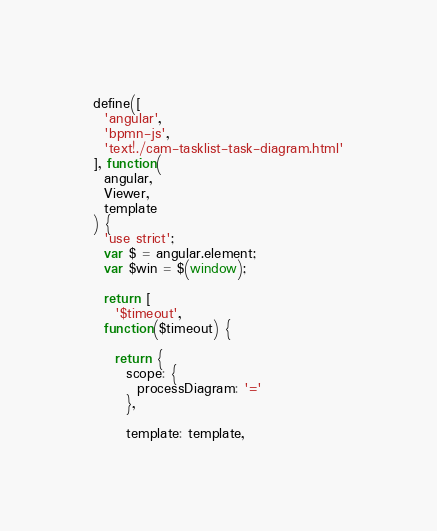Convert code to text. <code><loc_0><loc_0><loc_500><loc_500><_JavaScript_>define([
  'angular',
  'bpmn-js',
  'text!./cam-tasklist-task-diagram.html'
], function(
  angular,
  Viewer,
  template
) {
  'use strict';
  var $ = angular.element;
  var $win = $(window);

  return [
    '$timeout',
  function($timeout) {

    return {
      scope: {
        processDiagram: '='
      },

      template: template,
</code> 